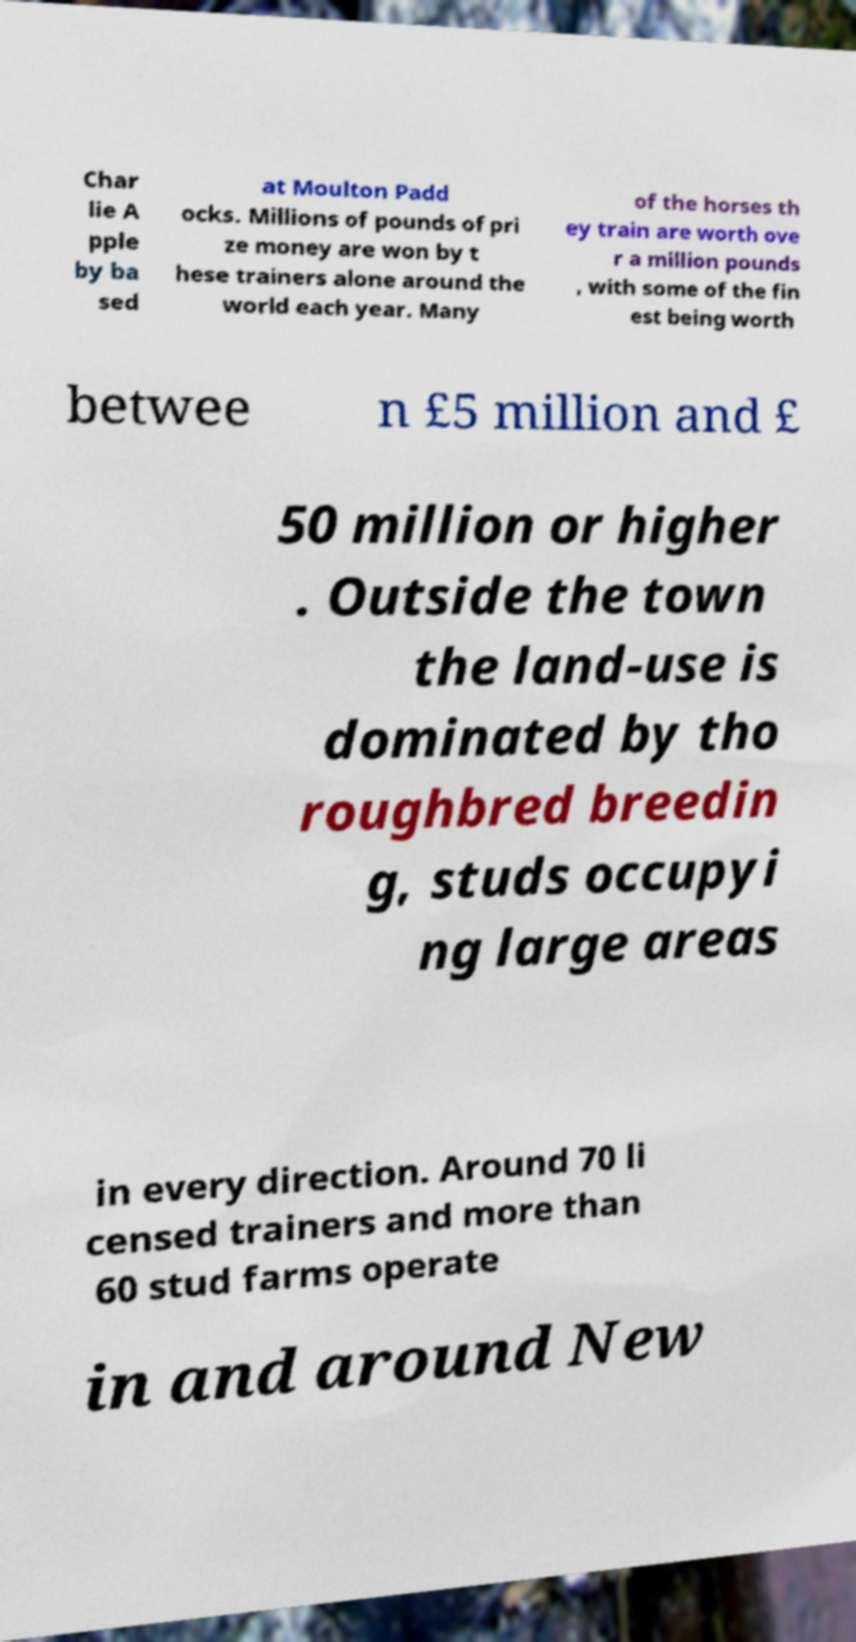Could you assist in decoding the text presented in this image and type it out clearly? Char lie A pple by ba sed at Moulton Padd ocks. Millions of pounds of pri ze money are won by t hese trainers alone around the world each year. Many of the horses th ey train are worth ove r a million pounds , with some of the fin est being worth betwee n £5 million and £ 50 million or higher . Outside the town the land-use is dominated by tho roughbred breedin g, studs occupyi ng large areas in every direction. Around 70 li censed trainers and more than 60 stud farms operate in and around New 